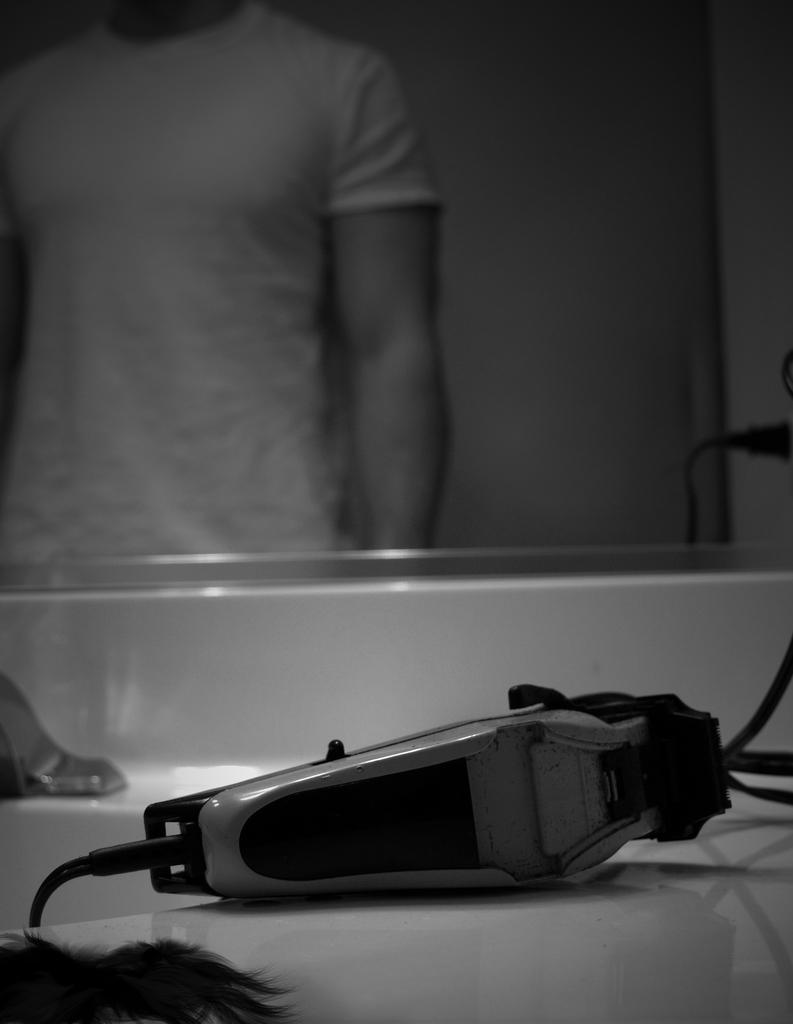What is the color scheme of the image? The image is black and white. What can be seen in the foreground of the image? There is an object in the foreground of the image. What is a reflective object visible in the image? There is a mirror visible in the image. What is reflected in the mirror? In the mirror, it appears that there is a person standing. What type of building is visible in the image? There is no building visible in the image; it primarily features an object, a mirror, and a reflection of a person. What type of flesh can be seen in the image? There is no flesh visible in the image; it is a black and white photograph with a mirror and a reflection of a person. 